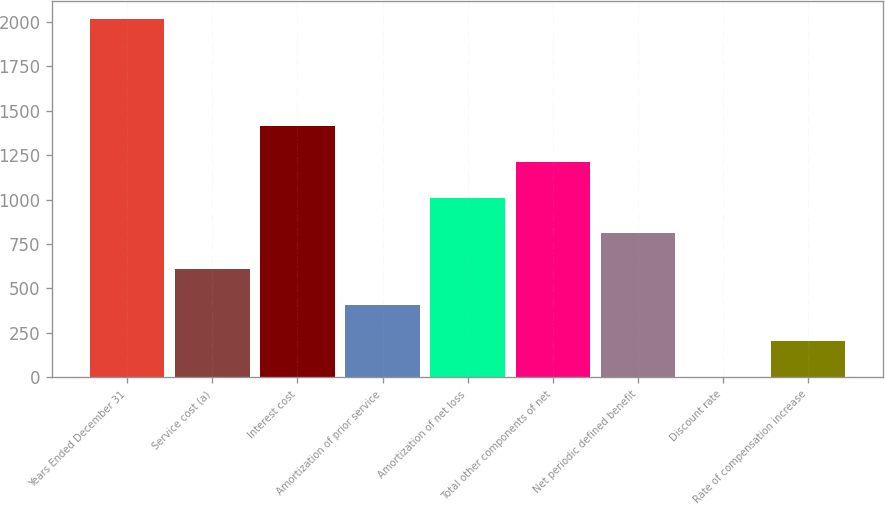<chart> <loc_0><loc_0><loc_500><loc_500><bar_chart><fcel>Years Ended December 31<fcel>Service cost (a)<fcel>Interest cost<fcel>Amortization of prior service<fcel>Amortization of net loss<fcel>Total other components of net<fcel>Net periodic defined benefit<fcel>Discount rate<fcel>Rate of compensation increase<nl><fcel>2018<fcel>608.03<fcel>1413.75<fcel>406.6<fcel>1010.89<fcel>1212.32<fcel>809.46<fcel>3.74<fcel>205.17<nl></chart> 